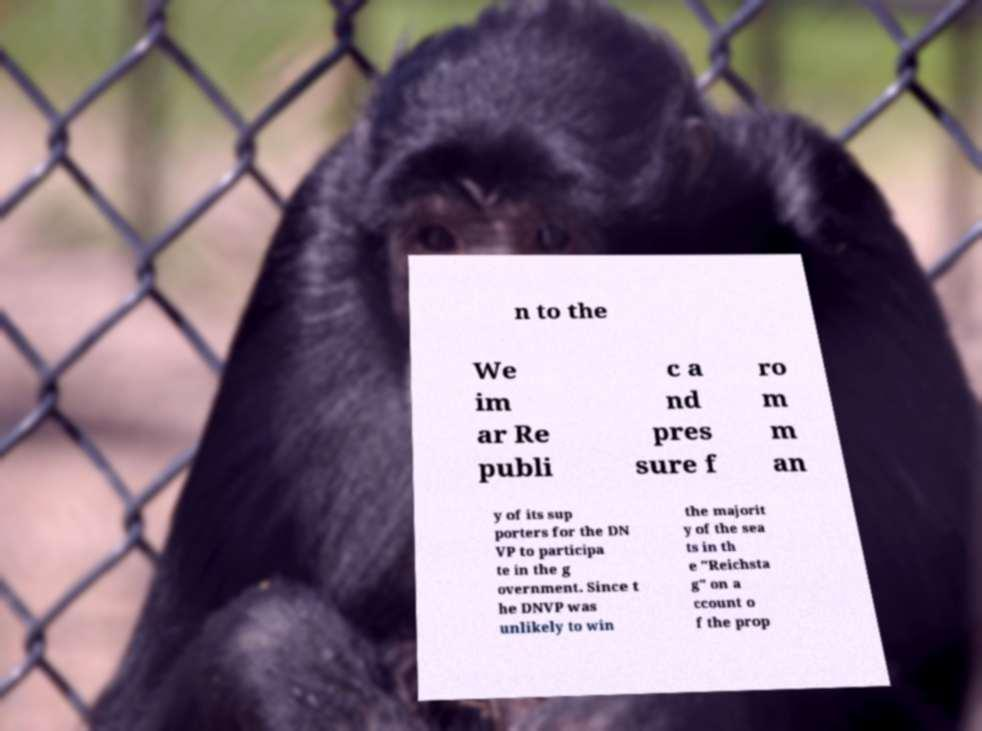Please read and relay the text visible in this image. What does it say? n to the We im ar Re publi c a nd pres sure f ro m m an y of its sup porters for the DN VP to participa te in the g overnment. Since t he DNVP was unlikely to win the majorit y of the sea ts in th e "Reichsta g" on a ccount o f the prop 